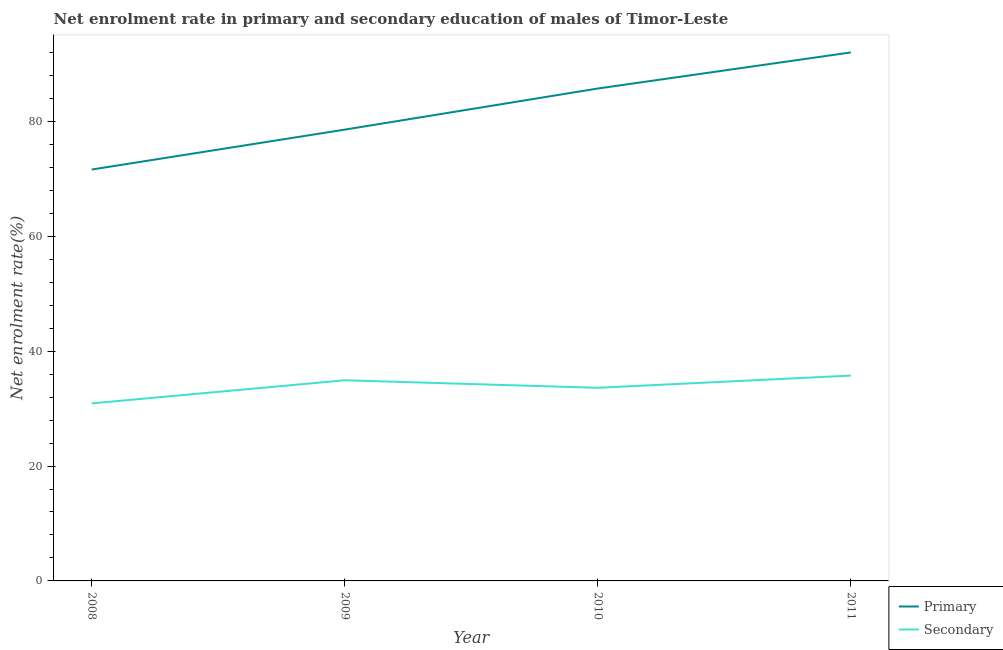What is the enrollment rate in secondary education in 2009?
Provide a succinct answer. 34.93. Across all years, what is the maximum enrollment rate in primary education?
Your answer should be compact. 92.02. Across all years, what is the minimum enrollment rate in secondary education?
Give a very brief answer. 30.91. In which year was the enrollment rate in primary education minimum?
Ensure brevity in your answer.  2008. What is the total enrollment rate in primary education in the graph?
Your response must be concise. 327.95. What is the difference between the enrollment rate in primary education in 2008 and that in 2011?
Give a very brief answer. -20.39. What is the difference between the enrollment rate in secondary education in 2009 and the enrollment rate in primary education in 2008?
Provide a succinct answer. -36.69. What is the average enrollment rate in primary education per year?
Your answer should be compact. 81.99. In the year 2011, what is the difference between the enrollment rate in primary education and enrollment rate in secondary education?
Your answer should be compact. 56.26. In how many years, is the enrollment rate in primary education greater than 16 %?
Offer a very short reply. 4. What is the ratio of the enrollment rate in primary education in 2008 to that in 2009?
Make the answer very short. 0.91. What is the difference between the highest and the second highest enrollment rate in primary education?
Your answer should be compact. 6.28. What is the difference between the highest and the lowest enrollment rate in secondary education?
Your response must be concise. 4.84. Is the sum of the enrollment rate in primary education in 2008 and 2009 greater than the maximum enrollment rate in secondary education across all years?
Your answer should be very brief. Yes. Is the enrollment rate in primary education strictly less than the enrollment rate in secondary education over the years?
Your answer should be very brief. No. How many lines are there?
Your response must be concise. 2. How many years are there in the graph?
Keep it short and to the point. 4. What is the difference between two consecutive major ticks on the Y-axis?
Your answer should be very brief. 20. Are the values on the major ticks of Y-axis written in scientific E-notation?
Your response must be concise. No. Does the graph contain any zero values?
Ensure brevity in your answer.  No. Where does the legend appear in the graph?
Offer a very short reply. Bottom right. How many legend labels are there?
Your answer should be compact. 2. What is the title of the graph?
Ensure brevity in your answer.  Net enrolment rate in primary and secondary education of males of Timor-Leste. What is the label or title of the Y-axis?
Your answer should be very brief. Net enrolment rate(%). What is the Net enrolment rate(%) in Primary in 2008?
Offer a very short reply. 71.63. What is the Net enrolment rate(%) of Secondary in 2008?
Ensure brevity in your answer.  30.91. What is the Net enrolment rate(%) of Primary in 2009?
Provide a succinct answer. 78.57. What is the Net enrolment rate(%) of Secondary in 2009?
Your response must be concise. 34.93. What is the Net enrolment rate(%) of Primary in 2010?
Offer a terse response. 85.73. What is the Net enrolment rate(%) in Secondary in 2010?
Provide a short and direct response. 33.62. What is the Net enrolment rate(%) of Primary in 2011?
Make the answer very short. 92.02. What is the Net enrolment rate(%) of Secondary in 2011?
Keep it short and to the point. 35.75. Across all years, what is the maximum Net enrolment rate(%) of Primary?
Make the answer very short. 92.02. Across all years, what is the maximum Net enrolment rate(%) of Secondary?
Offer a terse response. 35.75. Across all years, what is the minimum Net enrolment rate(%) in Primary?
Offer a terse response. 71.63. Across all years, what is the minimum Net enrolment rate(%) in Secondary?
Give a very brief answer. 30.91. What is the total Net enrolment rate(%) of Primary in the graph?
Keep it short and to the point. 327.95. What is the total Net enrolment rate(%) of Secondary in the graph?
Provide a short and direct response. 135.22. What is the difference between the Net enrolment rate(%) in Primary in 2008 and that in 2009?
Your response must be concise. -6.95. What is the difference between the Net enrolment rate(%) in Secondary in 2008 and that in 2009?
Offer a terse response. -4.03. What is the difference between the Net enrolment rate(%) in Primary in 2008 and that in 2010?
Provide a succinct answer. -14.11. What is the difference between the Net enrolment rate(%) of Secondary in 2008 and that in 2010?
Your answer should be very brief. -2.72. What is the difference between the Net enrolment rate(%) in Primary in 2008 and that in 2011?
Your answer should be compact. -20.39. What is the difference between the Net enrolment rate(%) of Secondary in 2008 and that in 2011?
Provide a succinct answer. -4.84. What is the difference between the Net enrolment rate(%) in Primary in 2009 and that in 2010?
Your answer should be compact. -7.16. What is the difference between the Net enrolment rate(%) in Secondary in 2009 and that in 2010?
Your answer should be compact. 1.31. What is the difference between the Net enrolment rate(%) in Primary in 2009 and that in 2011?
Ensure brevity in your answer.  -13.44. What is the difference between the Net enrolment rate(%) of Secondary in 2009 and that in 2011?
Your response must be concise. -0.82. What is the difference between the Net enrolment rate(%) in Primary in 2010 and that in 2011?
Provide a succinct answer. -6.28. What is the difference between the Net enrolment rate(%) in Secondary in 2010 and that in 2011?
Keep it short and to the point. -2.13. What is the difference between the Net enrolment rate(%) in Primary in 2008 and the Net enrolment rate(%) in Secondary in 2009?
Give a very brief answer. 36.69. What is the difference between the Net enrolment rate(%) in Primary in 2008 and the Net enrolment rate(%) in Secondary in 2010?
Ensure brevity in your answer.  38. What is the difference between the Net enrolment rate(%) of Primary in 2008 and the Net enrolment rate(%) of Secondary in 2011?
Provide a succinct answer. 35.87. What is the difference between the Net enrolment rate(%) of Primary in 2009 and the Net enrolment rate(%) of Secondary in 2010?
Keep it short and to the point. 44.95. What is the difference between the Net enrolment rate(%) of Primary in 2009 and the Net enrolment rate(%) of Secondary in 2011?
Your response must be concise. 42.82. What is the difference between the Net enrolment rate(%) of Primary in 2010 and the Net enrolment rate(%) of Secondary in 2011?
Offer a terse response. 49.98. What is the average Net enrolment rate(%) in Primary per year?
Your response must be concise. 81.99. What is the average Net enrolment rate(%) in Secondary per year?
Your answer should be compact. 33.8. In the year 2008, what is the difference between the Net enrolment rate(%) in Primary and Net enrolment rate(%) in Secondary?
Your answer should be very brief. 40.72. In the year 2009, what is the difference between the Net enrolment rate(%) of Primary and Net enrolment rate(%) of Secondary?
Offer a very short reply. 43.64. In the year 2010, what is the difference between the Net enrolment rate(%) in Primary and Net enrolment rate(%) in Secondary?
Offer a very short reply. 52.11. In the year 2011, what is the difference between the Net enrolment rate(%) in Primary and Net enrolment rate(%) in Secondary?
Provide a short and direct response. 56.26. What is the ratio of the Net enrolment rate(%) of Primary in 2008 to that in 2009?
Your answer should be very brief. 0.91. What is the ratio of the Net enrolment rate(%) of Secondary in 2008 to that in 2009?
Offer a very short reply. 0.88. What is the ratio of the Net enrolment rate(%) of Primary in 2008 to that in 2010?
Give a very brief answer. 0.84. What is the ratio of the Net enrolment rate(%) in Secondary in 2008 to that in 2010?
Offer a very short reply. 0.92. What is the ratio of the Net enrolment rate(%) in Primary in 2008 to that in 2011?
Give a very brief answer. 0.78. What is the ratio of the Net enrolment rate(%) of Secondary in 2008 to that in 2011?
Make the answer very short. 0.86. What is the ratio of the Net enrolment rate(%) of Primary in 2009 to that in 2010?
Your response must be concise. 0.92. What is the ratio of the Net enrolment rate(%) in Secondary in 2009 to that in 2010?
Make the answer very short. 1.04. What is the ratio of the Net enrolment rate(%) in Primary in 2009 to that in 2011?
Your response must be concise. 0.85. What is the ratio of the Net enrolment rate(%) in Secondary in 2009 to that in 2011?
Provide a succinct answer. 0.98. What is the ratio of the Net enrolment rate(%) of Primary in 2010 to that in 2011?
Provide a succinct answer. 0.93. What is the ratio of the Net enrolment rate(%) in Secondary in 2010 to that in 2011?
Your answer should be very brief. 0.94. What is the difference between the highest and the second highest Net enrolment rate(%) of Primary?
Keep it short and to the point. 6.28. What is the difference between the highest and the second highest Net enrolment rate(%) in Secondary?
Make the answer very short. 0.82. What is the difference between the highest and the lowest Net enrolment rate(%) of Primary?
Your answer should be very brief. 20.39. What is the difference between the highest and the lowest Net enrolment rate(%) in Secondary?
Ensure brevity in your answer.  4.84. 